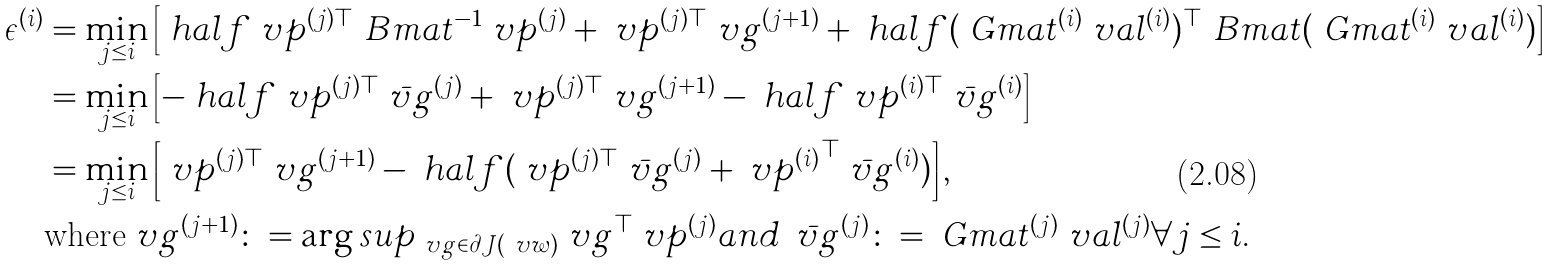Convert formula to latex. <formula><loc_0><loc_0><loc_500><loc_500>\epsilon ^ { ( i ) } & = \min _ { j \leq i } \left [ \ h a l f \ v p ^ { ( j ) \top } \ B m a t ^ { - 1 } \ v p ^ { ( j ) } + \ v p ^ { ( j ) \top } \ v g ^ { ( j + 1 ) } + \ h a l f ( \ G m a t ^ { ( i ) } \ v a l ^ { ( i ) } ) ^ { \top } \ B m a t ( \ G m a t ^ { ( i ) } \ v a l ^ { ( i ) } ) \right ] \\ & = \min _ { j \leq i } \left [ - \ h a l f \ v p ^ { ( j ) \top } \bar { \ v g } ^ { ( j ) } + \ v p ^ { ( j ) \top } \ v g ^ { ( j + 1 ) } - \ h a l f \ v p ^ { ( i ) \top } \bar { \ v g } ^ { ( i ) } \right ] \\ & = \min _ { j \leq i } \left [ \ v p ^ { ( j ) \top } \ v g ^ { ( j + 1 ) } - \ h a l f ( \ v p ^ { ( j ) \top } \bar { \ v g } ^ { ( j ) } + { \ v p ^ { ( i ) } } ^ { \top } \bar { \ v g } ^ { ( i ) } ) \right ] , \\ & \text {where} \ v g ^ { ( j + 1 ) } \colon = \arg s u p _ { \ v g \in \partial J ( \ v w ) } \ v g ^ { \top } \ v p ^ { ( j ) } a n d \, \bar { \ v g } ^ { ( j ) } \colon = \ G m a t ^ { ( j ) } \ v a l ^ { ( j ) } \forall j \leq i .</formula> 